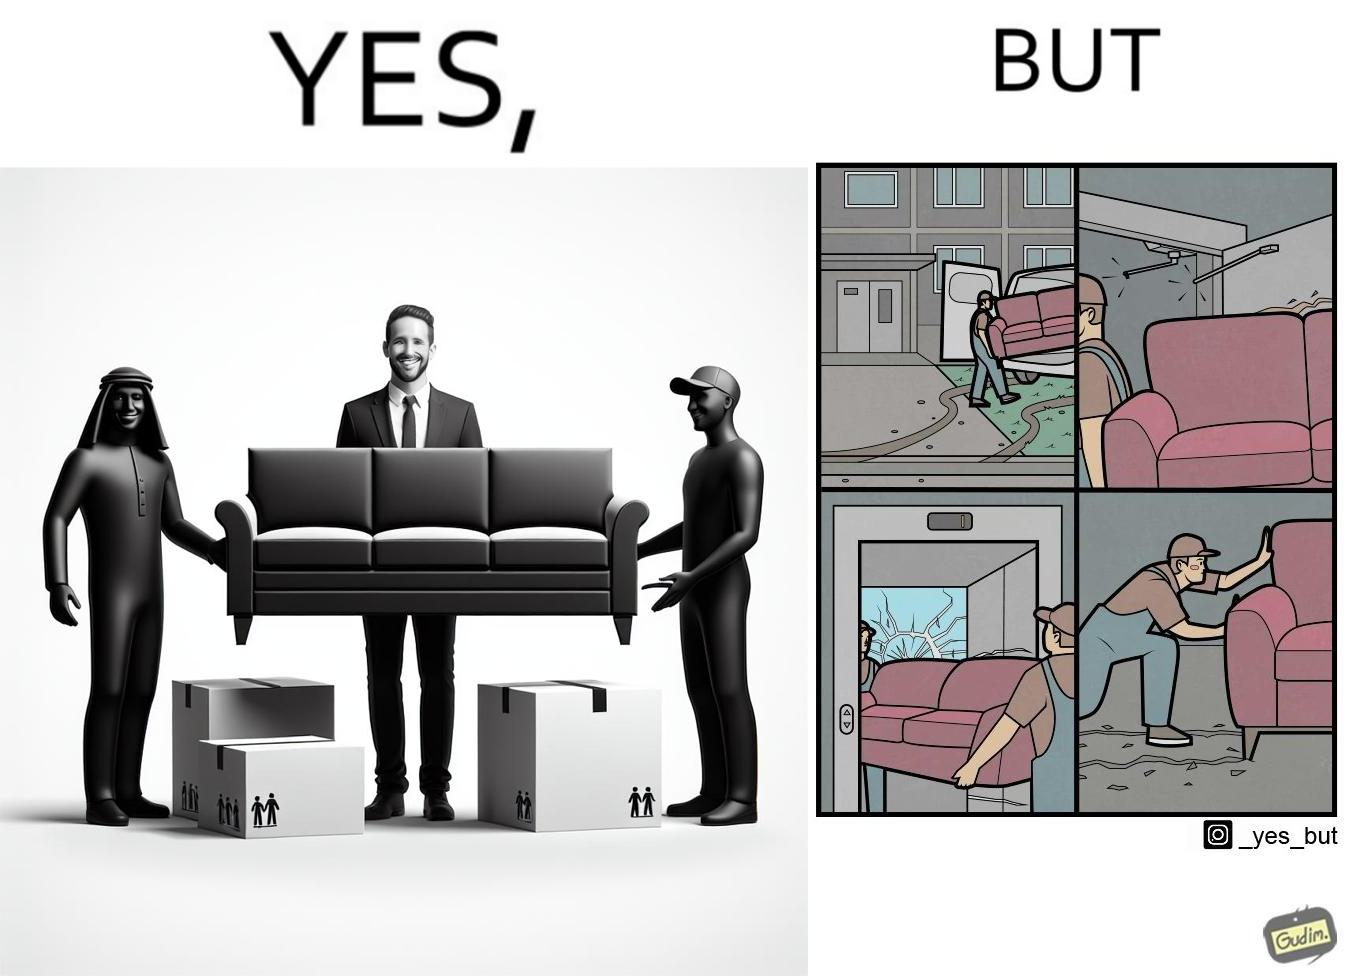Describe what you see in the left and right parts of this image. In the left part of the image: A man happy with movers who have helped move in a sofa In the right part of the image: Images show how movers have damaged a house while moving in furniture 